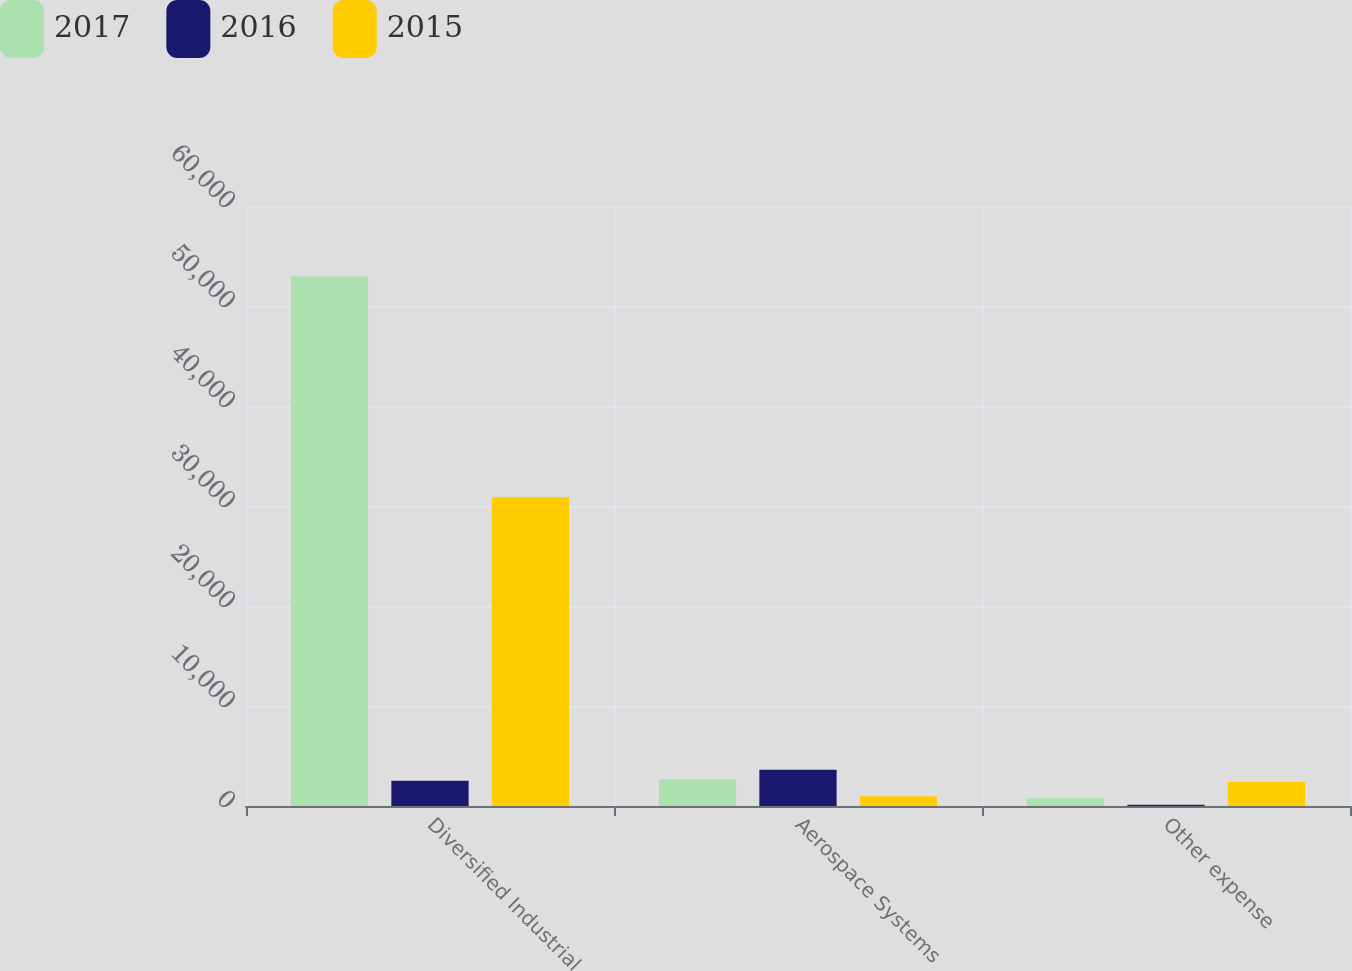Convert chart. <chart><loc_0><loc_0><loc_500><loc_500><stacked_bar_chart><ecel><fcel>Diversified Industrial<fcel>Aerospace Systems<fcel>Other expense<nl><fcel>2017<fcel>52939<fcel>2674<fcel>784<nl><fcel>2016<fcel>2536.5<fcel>3629<fcel>116<nl><fcel>2015<fcel>30882<fcel>967<fcel>2399<nl></chart> 